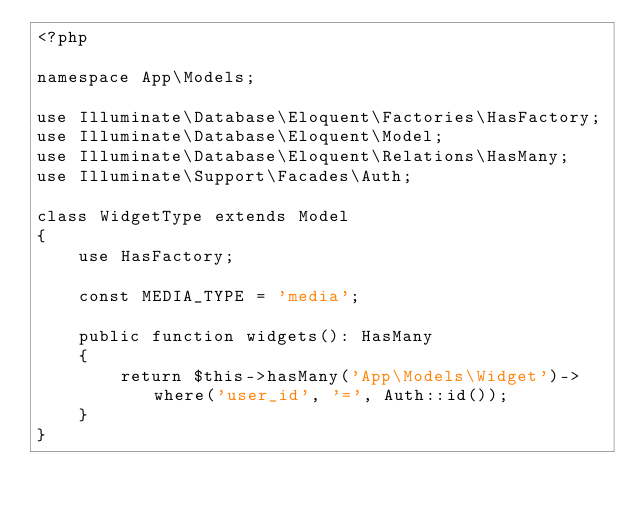<code> <loc_0><loc_0><loc_500><loc_500><_PHP_><?php

namespace App\Models;

use Illuminate\Database\Eloquent\Factories\HasFactory;
use Illuminate\Database\Eloquent\Model;
use Illuminate\Database\Eloquent\Relations\HasMany;
use Illuminate\Support\Facades\Auth;

class WidgetType extends Model
{
    use HasFactory;

    const MEDIA_TYPE = 'media';

    public function widgets(): HasMany
    {
        return $this->hasMany('App\Models\Widget')->where('user_id', '=', Auth::id());
    }
}
</code> 